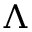Convert formula to latex. <formula><loc_0><loc_0><loc_500><loc_500>\Lambda</formula> 